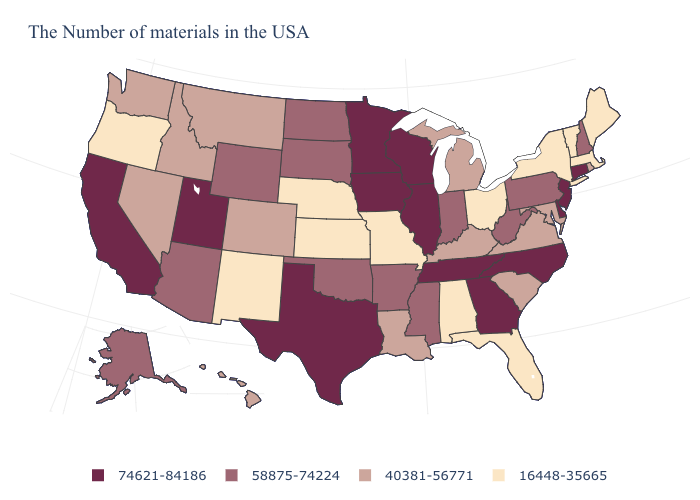Is the legend a continuous bar?
Keep it brief. No. Which states have the lowest value in the MidWest?
Answer briefly. Ohio, Missouri, Kansas, Nebraska. Name the states that have a value in the range 40381-56771?
Write a very short answer. Rhode Island, Maryland, Virginia, South Carolina, Michigan, Kentucky, Louisiana, Colorado, Montana, Idaho, Nevada, Washington, Hawaii. What is the highest value in the USA?
Keep it brief. 74621-84186. What is the highest value in states that border Massachusetts?
Concise answer only. 74621-84186. Which states hav the highest value in the Northeast?
Quick response, please. Connecticut, New Jersey. What is the value of Nebraska?
Write a very short answer. 16448-35665. Name the states that have a value in the range 40381-56771?
Write a very short answer. Rhode Island, Maryland, Virginia, South Carolina, Michigan, Kentucky, Louisiana, Colorado, Montana, Idaho, Nevada, Washington, Hawaii. Which states have the highest value in the USA?
Keep it brief. Connecticut, New Jersey, Delaware, North Carolina, Georgia, Tennessee, Wisconsin, Illinois, Minnesota, Iowa, Texas, Utah, California. Name the states that have a value in the range 16448-35665?
Be succinct. Maine, Massachusetts, Vermont, New York, Ohio, Florida, Alabama, Missouri, Kansas, Nebraska, New Mexico, Oregon. Among the states that border Nebraska , which have the highest value?
Answer briefly. Iowa. Name the states that have a value in the range 40381-56771?
Answer briefly. Rhode Island, Maryland, Virginia, South Carolina, Michigan, Kentucky, Louisiana, Colorado, Montana, Idaho, Nevada, Washington, Hawaii. What is the value of North Carolina?
Write a very short answer. 74621-84186. Name the states that have a value in the range 40381-56771?
Keep it brief. Rhode Island, Maryland, Virginia, South Carolina, Michigan, Kentucky, Louisiana, Colorado, Montana, Idaho, Nevada, Washington, Hawaii. 